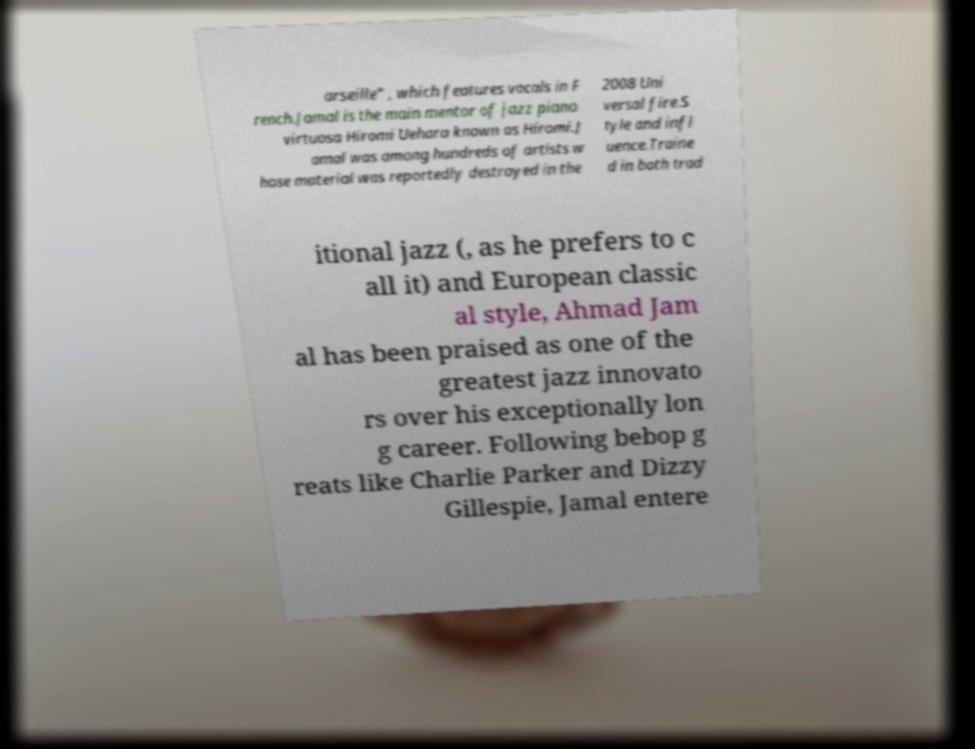There's text embedded in this image that I need extracted. Can you transcribe it verbatim? arseille" , which features vocals in F rench.Jamal is the main mentor of jazz piano virtuosa Hiromi Uehara known as Hiromi.J amal was among hundreds of artists w hose material was reportedly destroyed in the 2008 Uni versal fire.S tyle and infl uence.Traine d in both trad itional jazz (, as he prefers to c all it) and European classic al style, Ahmad Jam al has been praised as one of the greatest jazz innovato rs over his exceptionally lon g career. Following bebop g reats like Charlie Parker and Dizzy Gillespie, Jamal entere 